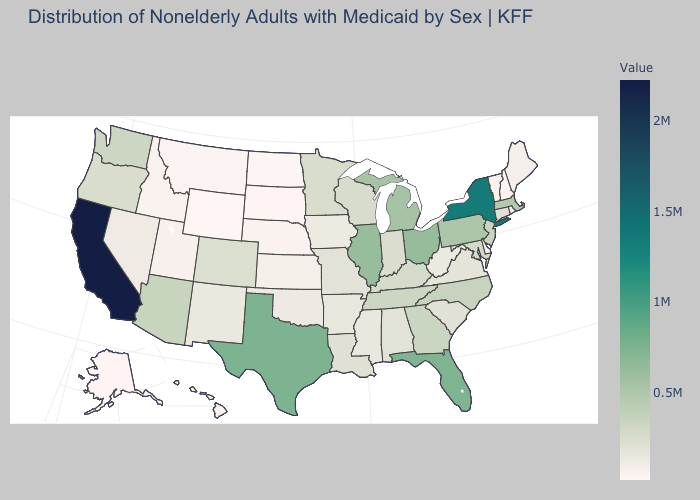Among the states that border Idaho , does Oregon have the lowest value?
Answer briefly. No. Which states have the highest value in the USA?
Keep it brief. California. Among the states that border Indiana , does Ohio have the highest value?
Short answer required. Yes. Is the legend a continuous bar?
Keep it brief. Yes. Does Montana have the highest value in the USA?
Answer briefly. No. Among the states that border Iowa , does Illinois have the highest value?
Keep it brief. Yes. Which states have the lowest value in the USA?
Quick response, please. Wyoming. 